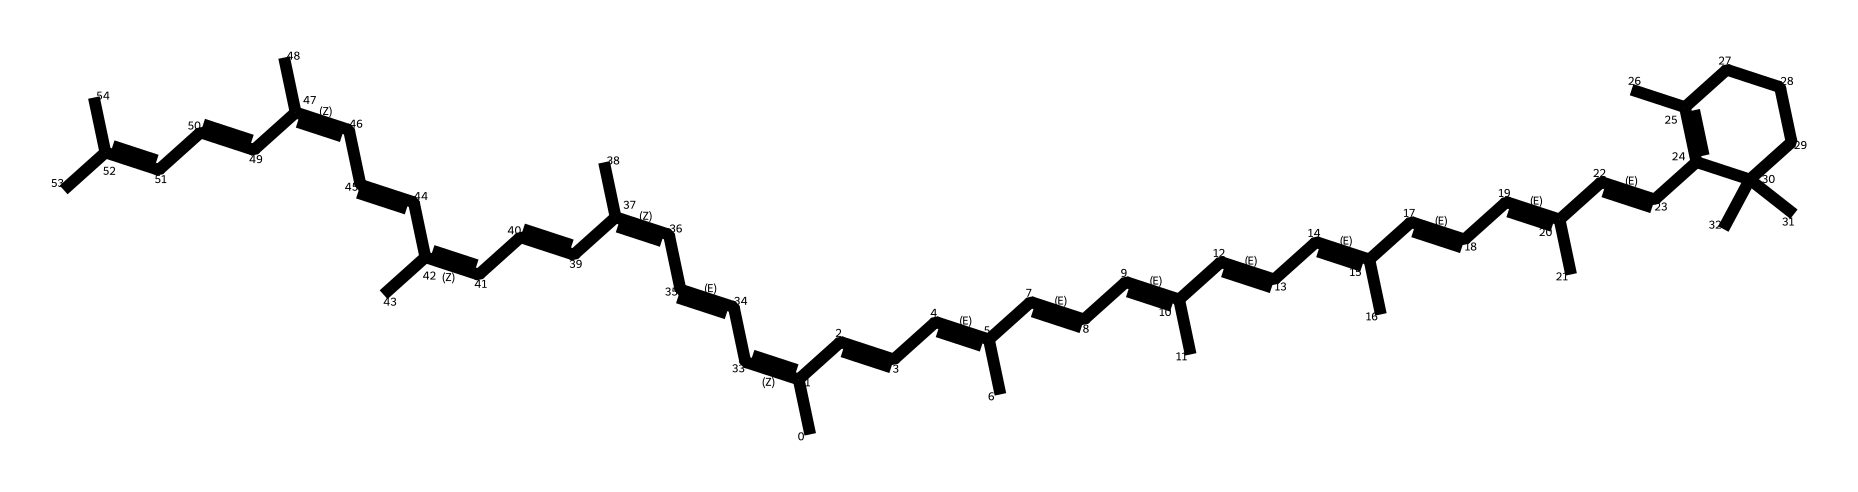What is the primary structural feature of lycopene? Lycopene is characterized by its long chain of conjugated double bonds, which is evident from the alternating double and single bonds in its structure.
Answer: conjugated double bonds How many carbon atoms are present in lycopene? To determine the number of carbon atoms, count the carbon symbols (C) in the SMILES representation. It shows there are a total of 40 carbon atoms.
Answer: 40 What type of chemical is lycopene classified as? Given its structure, which consists of many conjugated double bonds, lycopene is classified as a carotenoid, which is a type of antioxidant.
Answer: carotenoid How many rings does lycopene contain? By analyzing the SMILES, we can see that there are no closed ring structures, indicating that lycopene is a linear molecule.
Answer: 0 What property of lycopene links it to antioxidant activity? The presence of multiple conjugated double bonds in the structure allows for electron delocalization, which contributes to its ability to neutralize free radicals and exhibit antioxidant properties.
Answer: electron delocalization Does lycopene have functional groups typical of antioxidants? Lycopene lacks polar functional groups, but its extensive conjugated system compensates by providing significant antioxidant activity through its unique structure.
Answer: no functional groups 